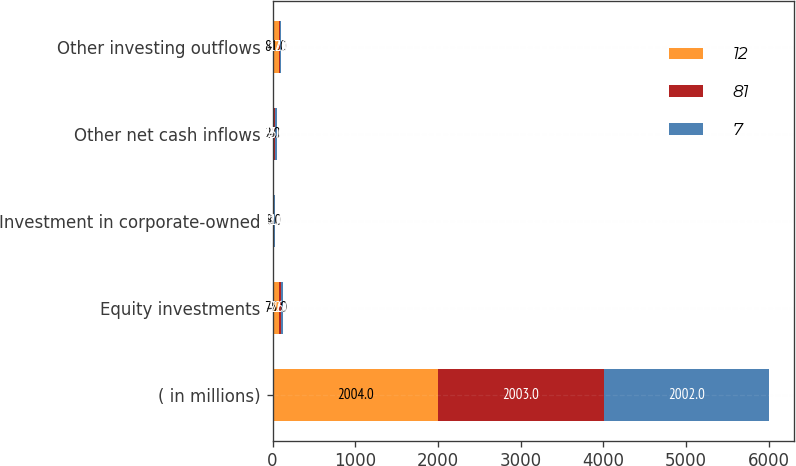<chart> <loc_0><loc_0><loc_500><loc_500><stacked_bar_chart><ecel><fcel>( in millions)<fcel>Equity investments<fcel>Investment in corporate-owned<fcel>Other net cash inflows<fcel>Other investing outflows<nl><fcel>12<fcel>2004<fcel>75<fcel>8<fcel>2<fcel>81<nl><fcel>81<fcel>2003<fcel>22<fcel>12<fcel>22<fcel>12<nl><fcel>7<fcel>2002<fcel>26<fcel>11<fcel>33<fcel>7<nl></chart> 